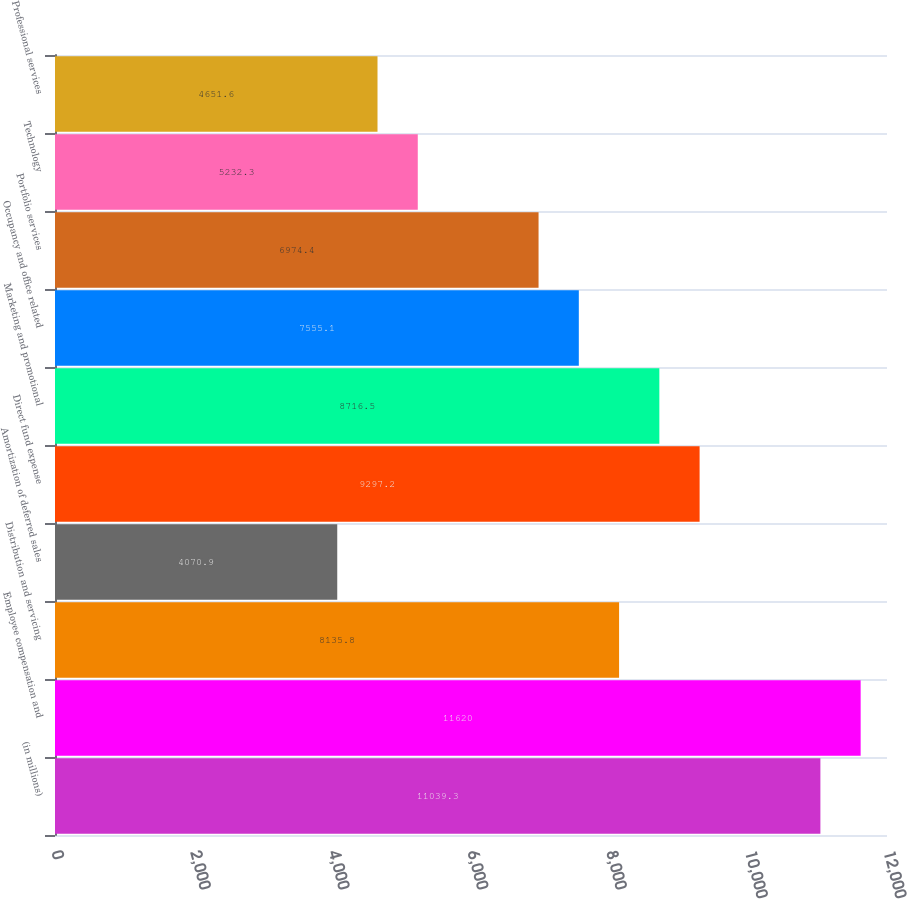Convert chart to OTSL. <chart><loc_0><loc_0><loc_500><loc_500><bar_chart><fcel>(in millions)<fcel>Employee compensation and<fcel>Distribution and servicing<fcel>Amortization of deferred sales<fcel>Direct fund expense<fcel>Marketing and promotional<fcel>Occupancy and office related<fcel>Portfolio services<fcel>Technology<fcel>Professional services<nl><fcel>11039.3<fcel>11620<fcel>8135.8<fcel>4070.9<fcel>9297.2<fcel>8716.5<fcel>7555.1<fcel>6974.4<fcel>5232.3<fcel>4651.6<nl></chart> 